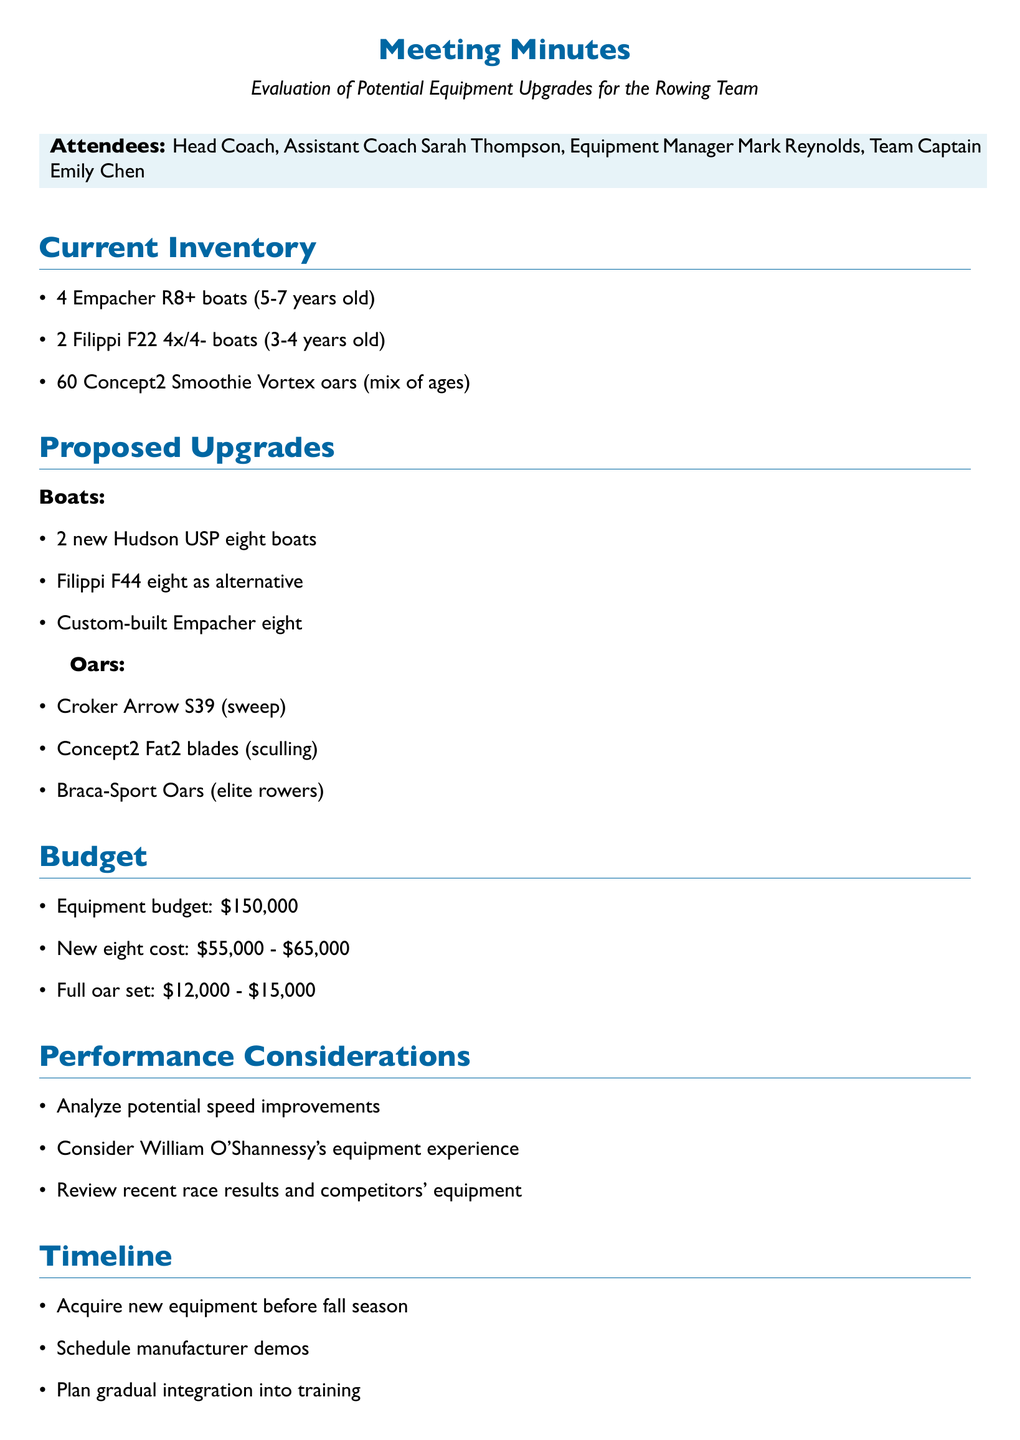What is the total number of Empacher R8+ boats? The document states there are 4 Empacher R8+ boats listed in the current equipment inventory.
Answer: 4 What is the estimated cost for a new eight boat? The document lists the estimated cost range for a new eight boat as $55,000 - $65,000.
Answer: $55,000 - $65,000 Who is the team captain? The document names Emily Chen as the team captain.
Answer: Emily Chen What equipment type is being analyzed for speed improvements? The document discusses potential speed improvements with new equipment, specifically focusing on boats and oars.
Answer: New equipment Which oar is suggested for sweep rowing? The notes specify testing Croker Arrow S39 oars for sweep rowing.
Answer: Croker Arrow S39 What is the current equipment budget? According to the document, the current equipment budget is $150,000.
Answer: $150,000 Who should be consulted regarding elite equipment preferences? The action items indicate that William O'Shannessy should be consulted on his equipment preferences from elite competitions.
Answer: William O'Shannessy What is the goal for new equipment acquisition? The document states the aim is to have new equipment before the fall season.
Answer: Before fall season What is one of the proposed upgrades for boats? The document proposes purchasing 2 new Hudson USP eight boats as a potential upgrade.
Answer: 2 new Hudson USP eight boats 